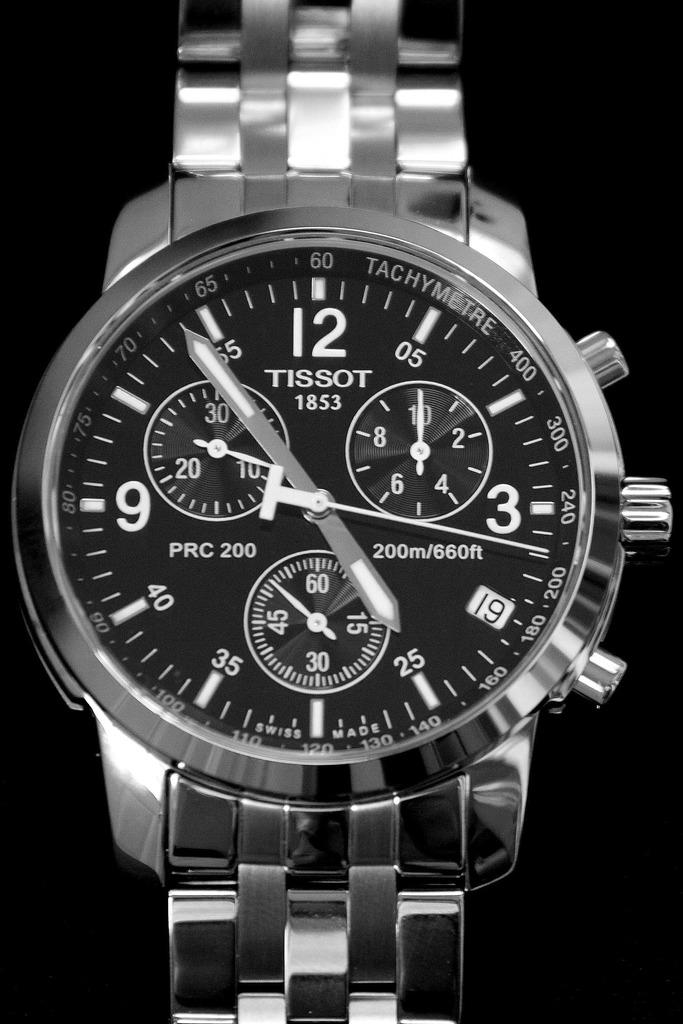Provide a one-sentence caption for the provided image. A very nice Tissot watch that is aluminum in nature. 